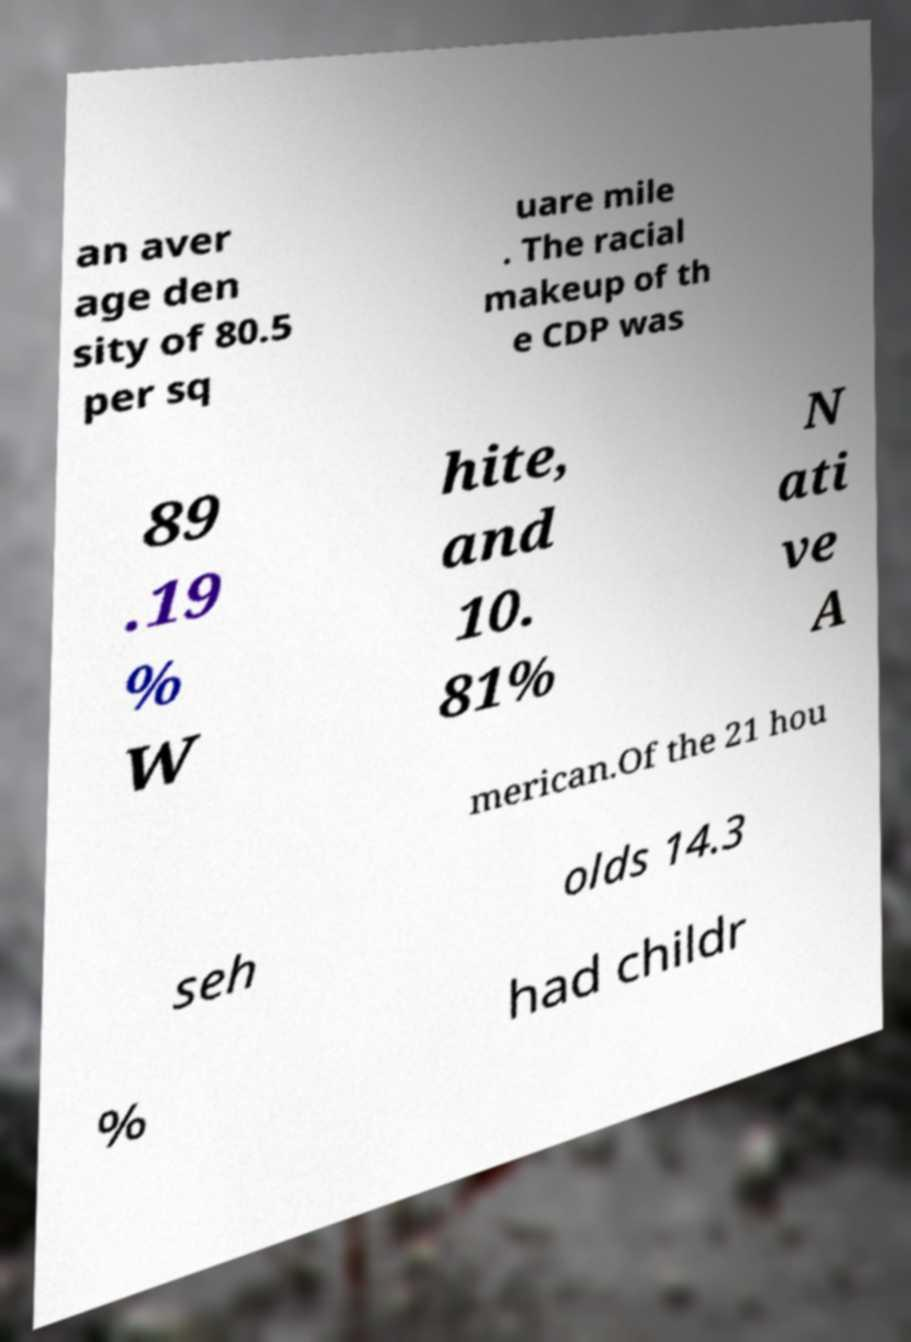For documentation purposes, I need the text within this image transcribed. Could you provide that? an aver age den sity of 80.5 per sq uare mile . The racial makeup of th e CDP was 89 .19 % W hite, and 10. 81% N ati ve A merican.Of the 21 hou seh olds 14.3 % had childr 